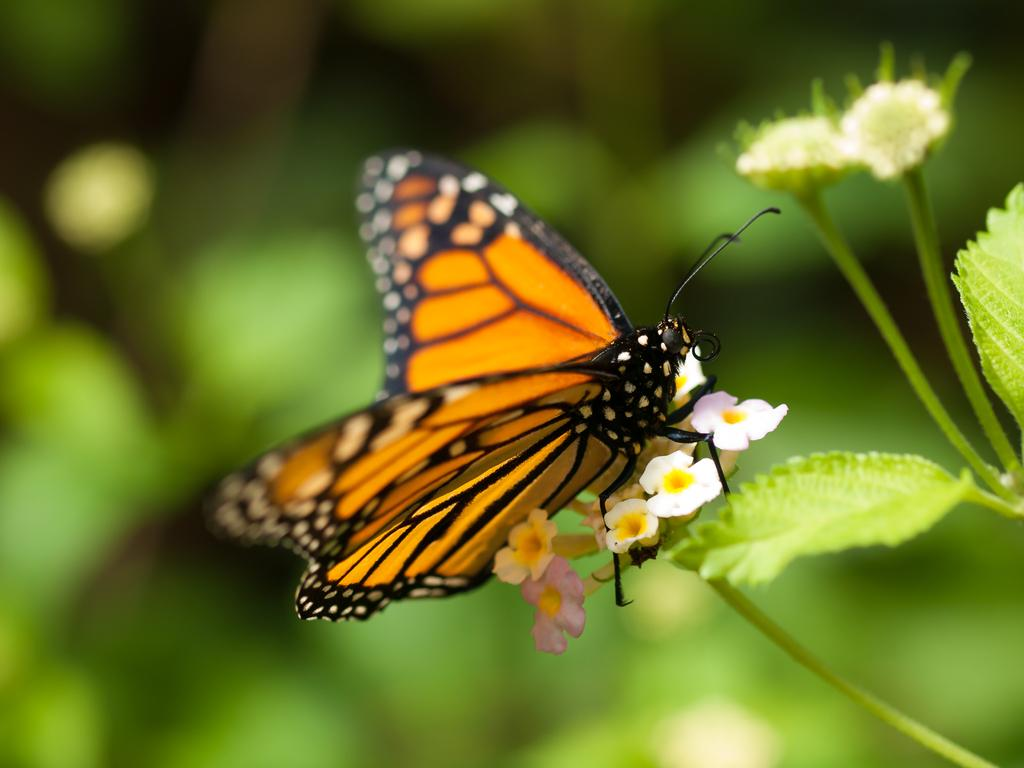What is on the flowers in the image? There is a butterfly on the flowers in the image. What type of plants are present in the image? There are flowers and buds with stems and leaves in the image. How would you describe the background of the image? The background of the image is green and blurred. What type of alley can be seen in the background of the image? There is no alley present in the image; the background is green and blurred. 